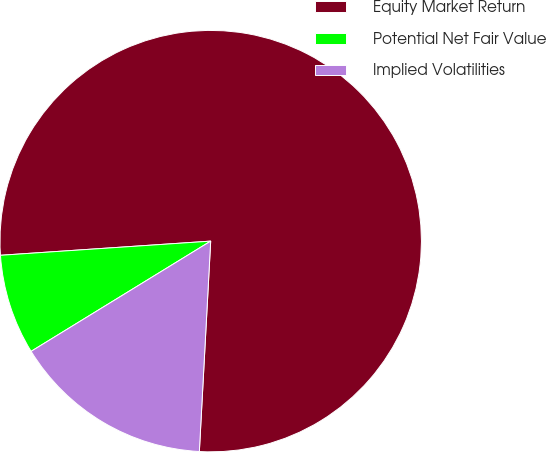Convert chart to OTSL. <chart><loc_0><loc_0><loc_500><loc_500><pie_chart><fcel>Equity Market Return<fcel>Potential Net Fair Value<fcel>Implied Volatilities<nl><fcel>76.92%<fcel>7.69%<fcel>15.38%<nl></chart> 